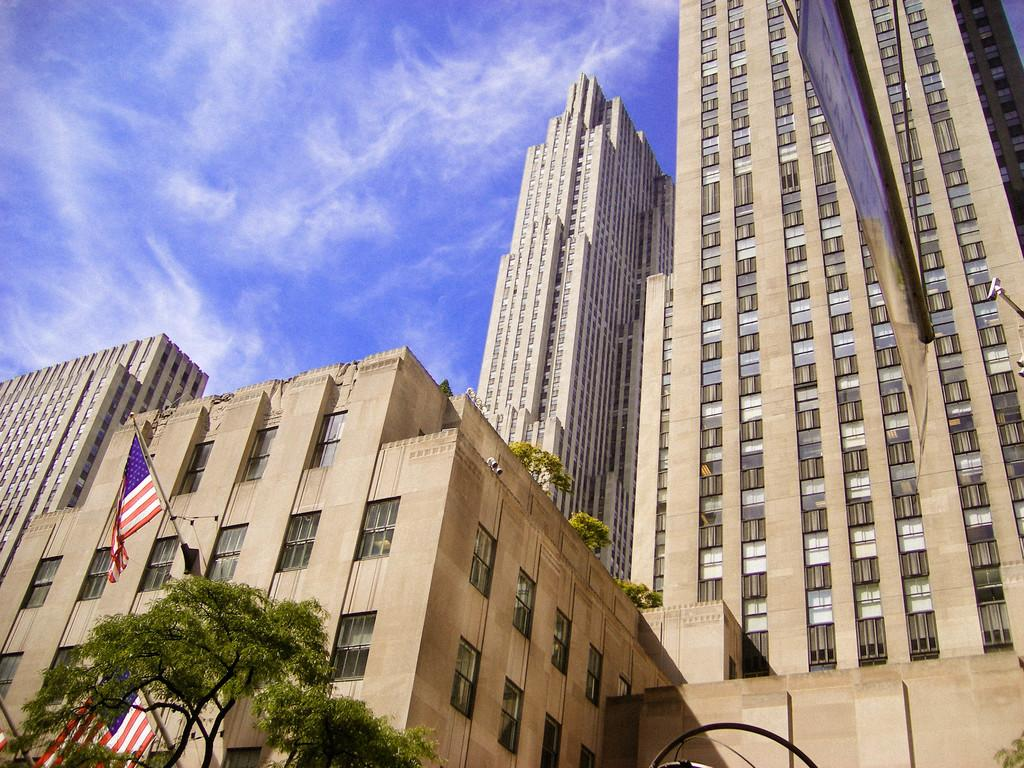What type of structures can be seen in the image? There are buildings in the image. What additional elements are present in the image? There are flags, trees, windows, a poster, and the sky is visible with clouds. Can you describe the poster in the image? Unfortunately, the provided facts do not give any information about the poster's content or appearance. What is the weather like in the image? The sky is visible with clouds, indicating that it might be partly cloudy. How many rings can be seen on the tree in the image? There are no rings mentioned in the image, and trees do not have rings visible to the naked eye. What type of horn is present in the image? There is no horn present in the image. 